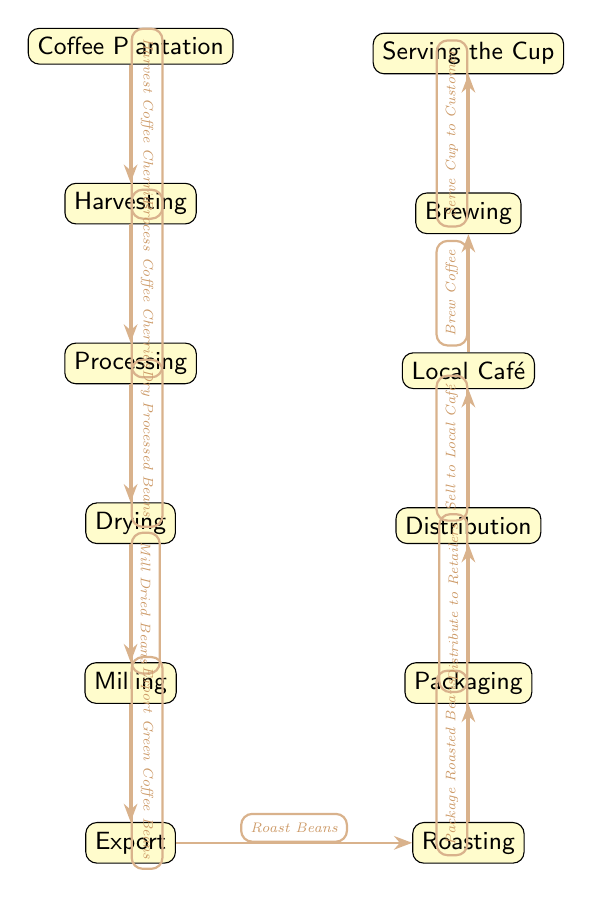What is the first step in the coffee-making process? The first node in the diagram represents the initiation of the process, which is the Coffee Plantation where coffee originates. Thus, the first step is the Coffee Plantation.
Answer: Coffee Plantation How many main steps are there in the diagram? Counting all the nodes from Coffee Plantation to Serving the Cup, there are a total of 11 distinct steps outlining the coffee-making process.
Answer: 11 What happens after harvesting? The diagram shows that after the Harvesting step, the next node is Processing, indicating the action that follows.
Answer: Processing What process comes before roasting? The diagram clearly indicates that Export is the step that leads up to Roasting, establishing the order of operations.
Answer: Export Which step involves packaging? According to the diagram, the step immediately prior to Distribution is Packaging; it is where the roasted beans are packaged.
Answer: Packaging How are coffee beans exported? The diagram shows a clear path where Milled Beans are exported as Green Coffee Beans, indicating the specific form of beans being exported.
Answer: Green Coffee Beans What is the last step before coffee is served? The penultimate step before Serving the Cup is Brewing, where the coffee is prepared to be served.
Answer: Brewing What type of establishment is the last step in the diagram? The final node in the flow is Local Café, which signifies the establishment that serves the coffee.
Answer: Local Café What is the action taken after the beans are roasted? After Rooasting, the next action taken is Packaging the roasted beans for distribution.
Answer: Packaging 